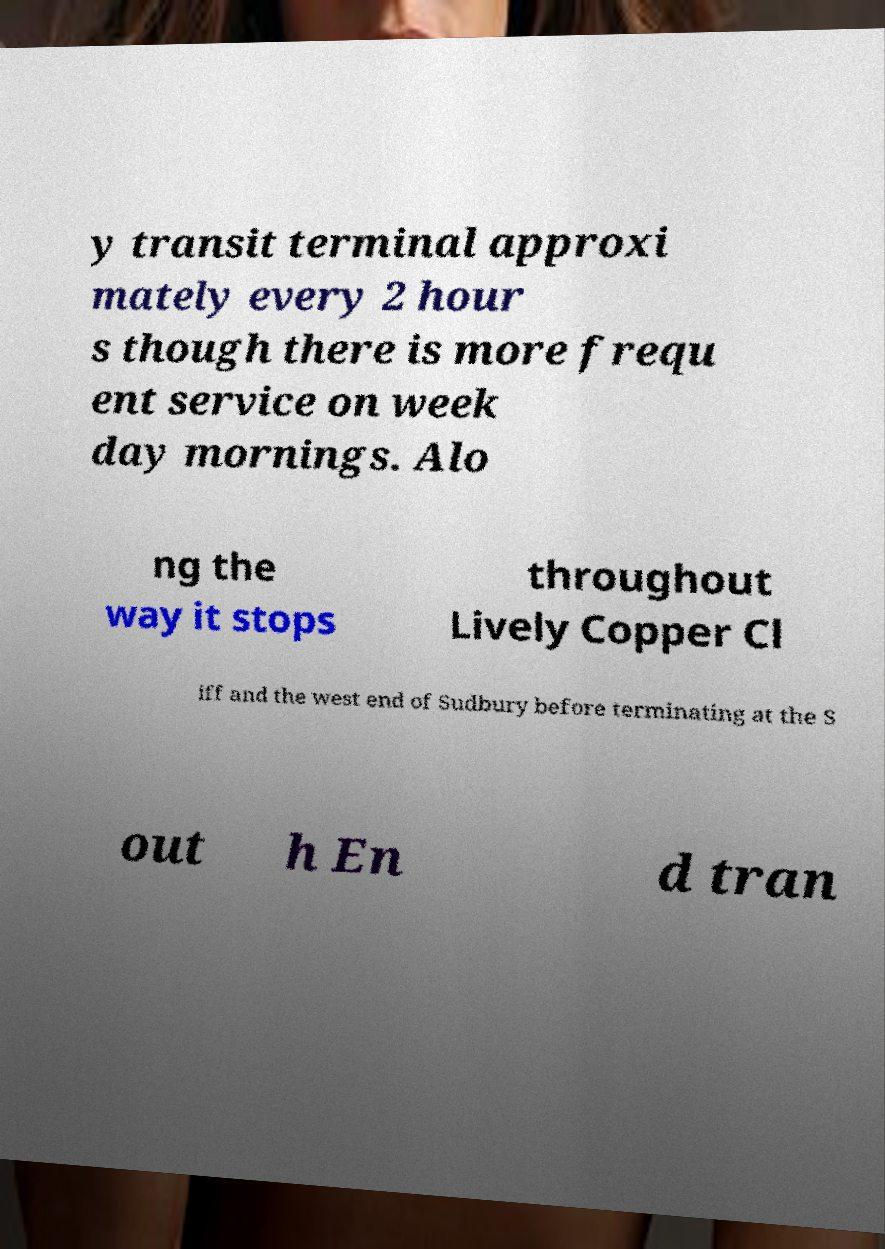Please identify and transcribe the text found in this image. y transit terminal approxi mately every 2 hour s though there is more frequ ent service on week day mornings. Alo ng the way it stops throughout Lively Copper Cl iff and the west end of Sudbury before terminating at the S out h En d tran 